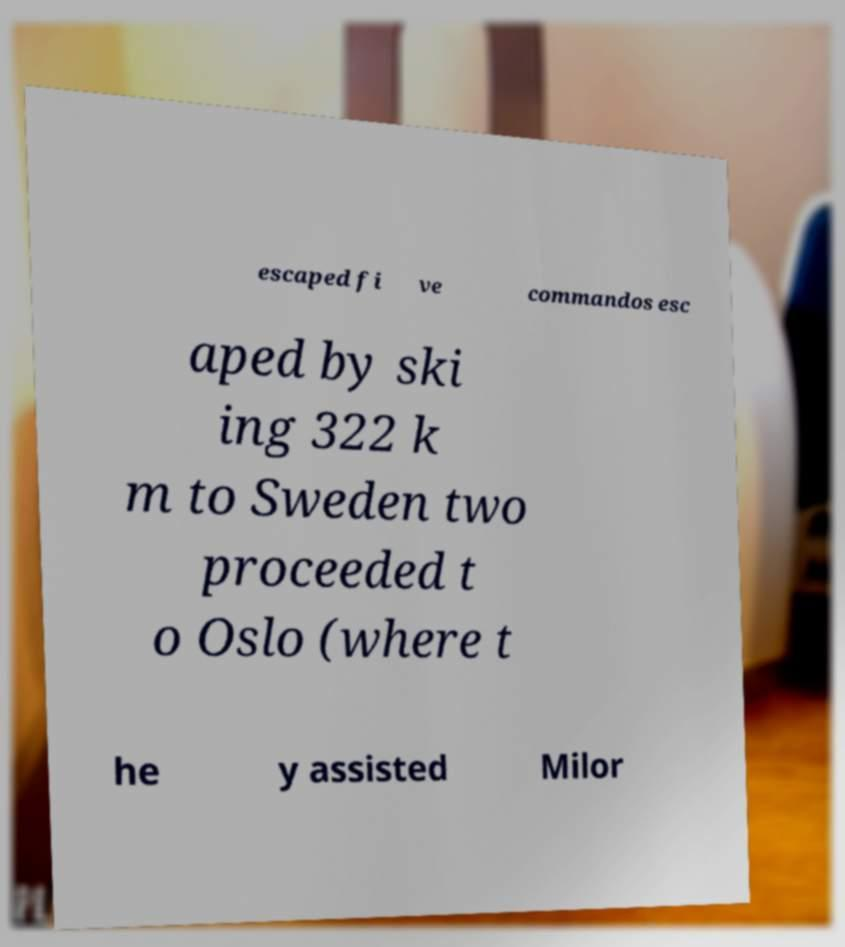For documentation purposes, I need the text within this image transcribed. Could you provide that? escaped fi ve commandos esc aped by ski ing 322 k m to Sweden two proceeded t o Oslo (where t he y assisted Milor 